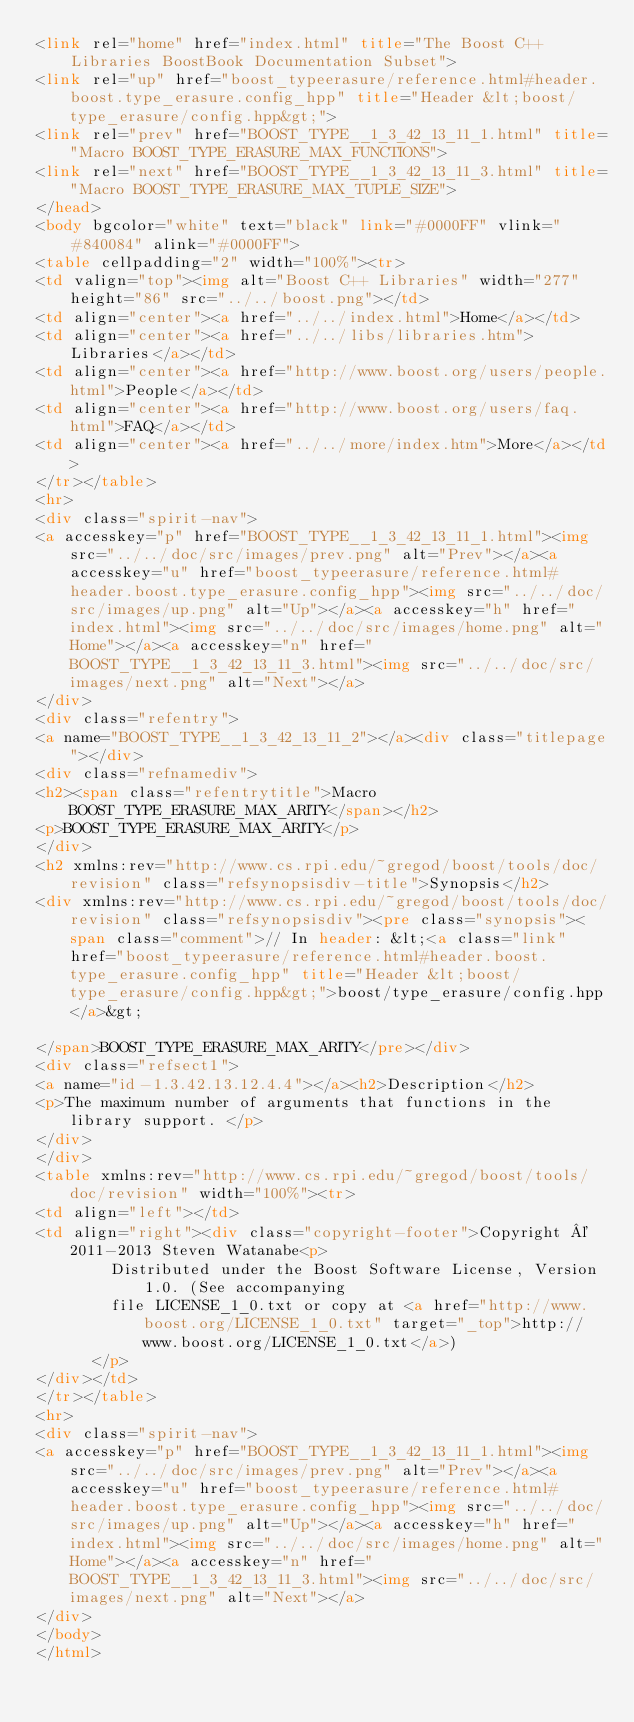<code> <loc_0><loc_0><loc_500><loc_500><_HTML_><link rel="home" href="index.html" title="The Boost C++ Libraries BoostBook Documentation Subset">
<link rel="up" href="boost_typeerasure/reference.html#header.boost.type_erasure.config_hpp" title="Header &lt;boost/type_erasure/config.hpp&gt;">
<link rel="prev" href="BOOST_TYPE__1_3_42_13_11_1.html" title="Macro BOOST_TYPE_ERASURE_MAX_FUNCTIONS">
<link rel="next" href="BOOST_TYPE__1_3_42_13_11_3.html" title="Macro BOOST_TYPE_ERASURE_MAX_TUPLE_SIZE">
</head>
<body bgcolor="white" text="black" link="#0000FF" vlink="#840084" alink="#0000FF">
<table cellpadding="2" width="100%"><tr>
<td valign="top"><img alt="Boost C++ Libraries" width="277" height="86" src="../../boost.png"></td>
<td align="center"><a href="../../index.html">Home</a></td>
<td align="center"><a href="../../libs/libraries.htm">Libraries</a></td>
<td align="center"><a href="http://www.boost.org/users/people.html">People</a></td>
<td align="center"><a href="http://www.boost.org/users/faq.html">FAQ</a></td>
<td align="center"><a href="../../more/index.htm">More</a></td>
</tr></table>
<hr>
<div class="spirit-nav">
<a accesskey="p" href="BOOST_TYPE__1_3_42_13_11_1.html"><img src="../../doc/src/images/prev.png" alt="Prev"></a><a accesskey="u" href="boost_typeerasure/reference.html#header.boost.type_erasure.config_hpp"><img src="../../doc/src/images/up.png" alt="Up"></a><a accesskey="h" href="index.html"><img src="../../doc/src/images/home.png" alt="Home"></a><a accesskey="n" href="BOOST_TYPE__1_3_42_13_11_3.html"><img src="../../doc/src/images/next.png" alt="Next"></a>
</div>
<div class="refentry">
<a name="BOOST_TYPE__1_3_42_13_11_2"></a><div class="titlepage"></div>
<div class="refnamediv">
<h2><span class="refentrytitle">Macro BOOST_TYPE_ERASURE_MAX_ARITY</span></h2>
<p>BOOST_TYPE_ERASURE_MAX_ARITY</p>
</div>
<h2 xmlns:rev="http://www.cs.rpi.edu/~gregod/boost/tools/doc/revision" class="refsynopsisdiv-title">Synopsis</h2>
<div xmlns:rev="http://www.cs.rpi.edu/~gregod/boost/tools/doc/revision" class="refsynopsisdiv"><pre class="synopsis"><span class="comment">// In header: &lt;<a class="link" href="boost_typeerasure/reference.html#header.boost.type_erasure.config_hpp" title="Header &lt;boost/type_erasure/config.hpp&gt;">boost/type_erasure/config.hpp</a>&gt;

</span>BOOST_TYPE_ERASURE_MAX_ARITY</pre></div>
<div class="refsect1">
<a name="id-1.3.42.13.12.4.4"></a><h2>Description</h2>
<p>The maximum number of arguments that functions in the library support. </p>
</div>
</div>
<table xmlns:rev="http://www.cs.rpi.edu/~gregod/boost/tools/doc/revision" width="100%"><tr>
<td align="left"></td>
<td align="right"><div class="copyright-footer">Copyright © 2011-2013 Steven Watanabe<p>
        Distributed under the Boost Software License, Version 1.0. (See accompanying
        file LICENSE_1_0.txt or copy at <a href="http://www.boost.org/LICENSE_1_0.txt" target="_top">http://www.boost.org/LICENSE_1_0.txt</a>)
      </p>
</div></td>
</tr></table>
<hr>
<div class="spirit-nav">
<a accesskey="p" href="BOOST_TYPE__1_3_42_13_11_1.html"><img src="../../doc/src/images/prev.png" alt="Prev"></a><a accesskey="u" href="boost_typeerasure/reference.html#header.boost.type_erasure.config_hpp"><img src="../../doc/src/images/up.png" alt="Up"></a><a accesskey="h" href="index.html"><img src="../../doc/src/images/home.png" alt="Home"></a><a accesskey="n" href="BOOST_TYPE__1_3_42_13_11_3.html"><img src="../../doc/src/images/next.png" alt="Next"></a>
</div>
</body>
</html>
</code> 